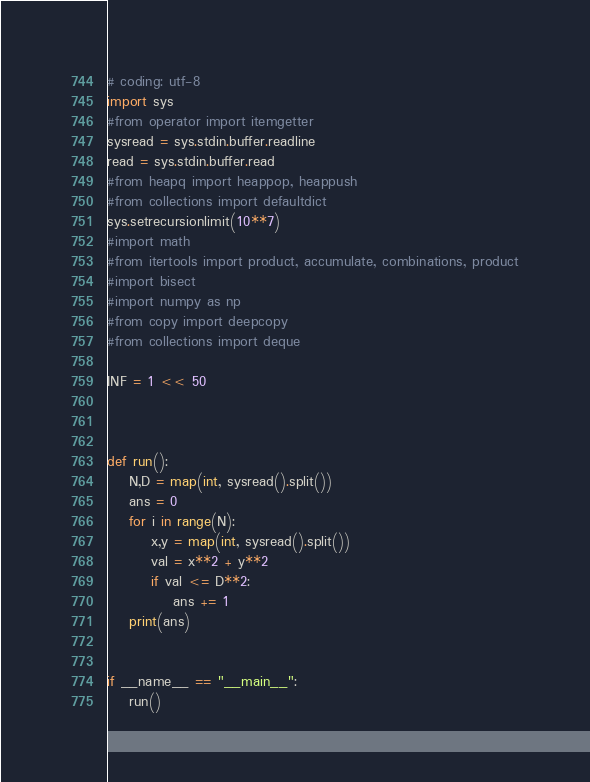<code> <loc_0><loc_0><loc_500><loc_500><_Python_># coding: utf-8
import sys
#from operator import itemgetter
sysread = sys.stdin.buffer.readline
read = sys.stdin.buffer.read
#from heapq import heappop, heappush
#from collections import defaultdict
sys.setrecursionlimit(10**7)
#import math
#from itertools import product, accumulate, combinations, product
#import bisect
#import numpy as np
#from copy import deepcopy
#from collections import deque

INF = 1 << 50



def run():
    N,D = map(int, sysread().split())
    ans = 0
    for i in range(N):
        x,y = map(int, sysread().split())
        val = x**2 + y**2
        if val <= D**2:
            ans += 1
    print(ans)


if __name__ == "__main__":
    run()</code> 